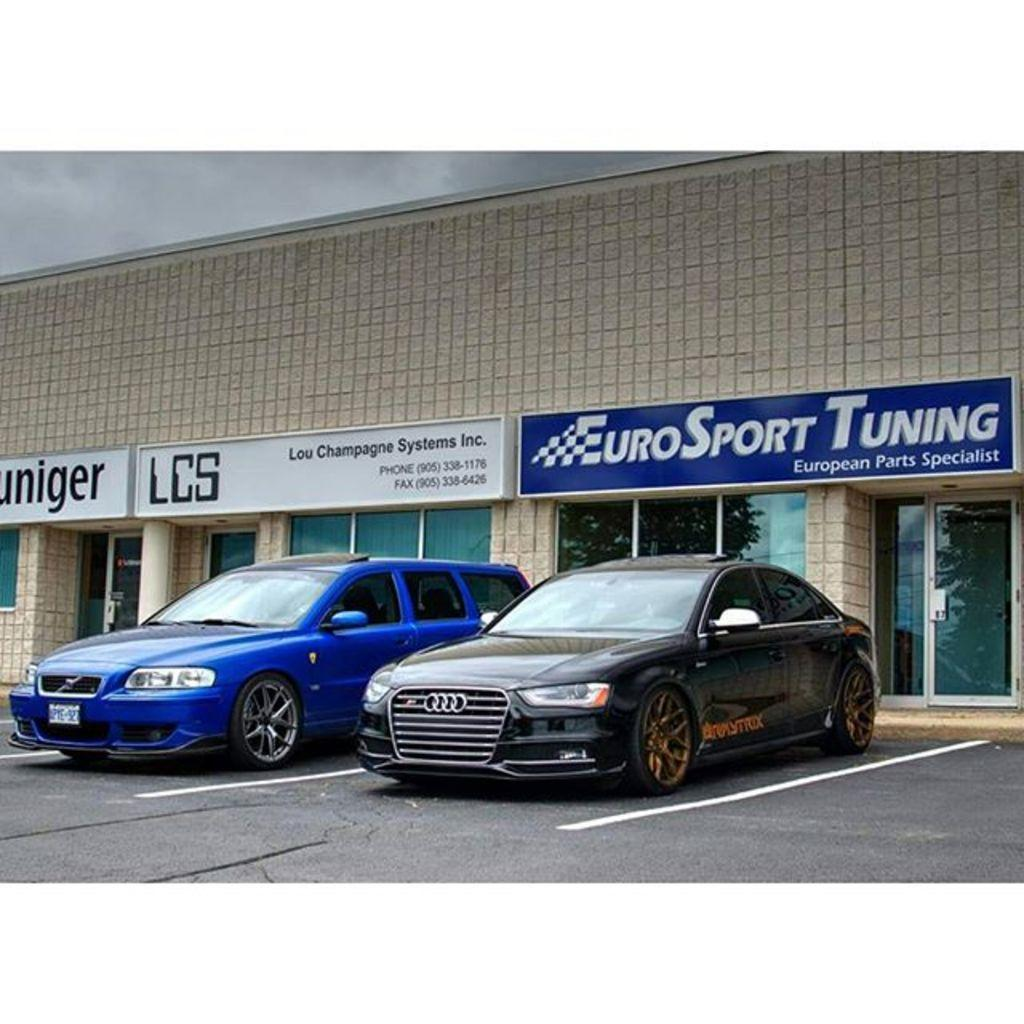What can be seen parked in the image? There are cars parked in the image. What type of structure is visible in the image? There is a building in the image. What is written on the wall in the image? There are name boards on the wall in the image. How would you describe the sky in the image? The sky is cloudy in the image. Can you see the ocean in the image? There is no ocean present in the image. How many nails are used to hold the name boards on the wall? The image does not provide information about the number of nails used to hold the name boards on the wall. 